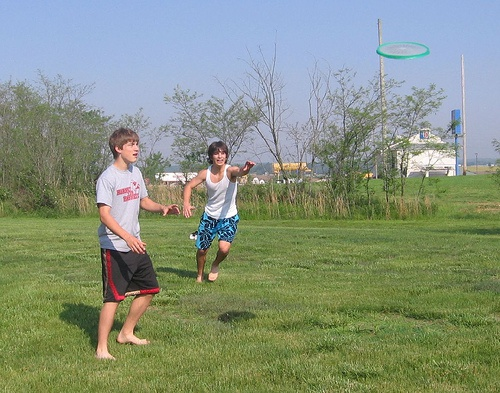Describe the objects in this image and their specific colors. I can see people in lightblue, lavender, salmon, black, and gray tones, people in lightblue, lightgray, salmon, darkgray, and gray tones, and frisbee in lightblue, darkgray, and turquoise tones in this image. 